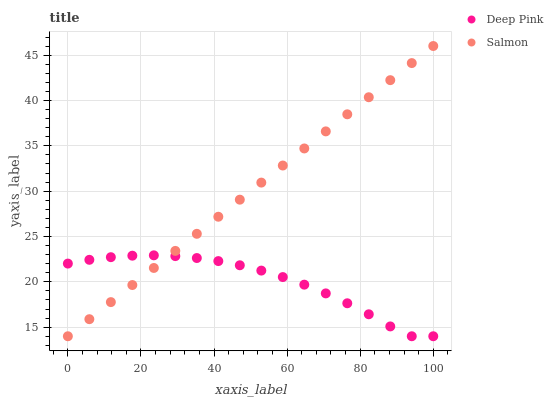Does Deep Pink have the minimum area under the curve?
Answer yes or no. Yes. Does Salmon have the maximum area under the curve?
Answer yes or no. Yes. Does Salmon have the minimum area under the curve?
Answer yes or no. No. Is Salmon the smoothest?
Answer yes or no. Yes. Is Deep Pink the roughest?
Answer yes or no. Yes. Is Salmon the roughest?
Answer yes or no. No. Does Deep Pink have the lowest value?
Answer yes or no. Yes. Does Salmon have the highest value?
Answer yes or no. Yes. Does Deep Pink intersect Salmon?
Answer yes or no. Yes. Is Deep Pink less than Salmon?
Answer yes or no. No. Is Deep Pink greater than Salmon?
Answer yes or no. No. 